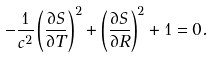Convert formula to latex. <formula><loc_0><loc_0><loc_500><loc_500>- \frac { 1 } { c ^ { 2 } } \left ( \frac { \partial S } { \partial T } \right ) ^ { 2 } + \left ( \frac { \partial S } { \partial R } \right ) ^ { 2 } + 1 = 0 .</formula> 